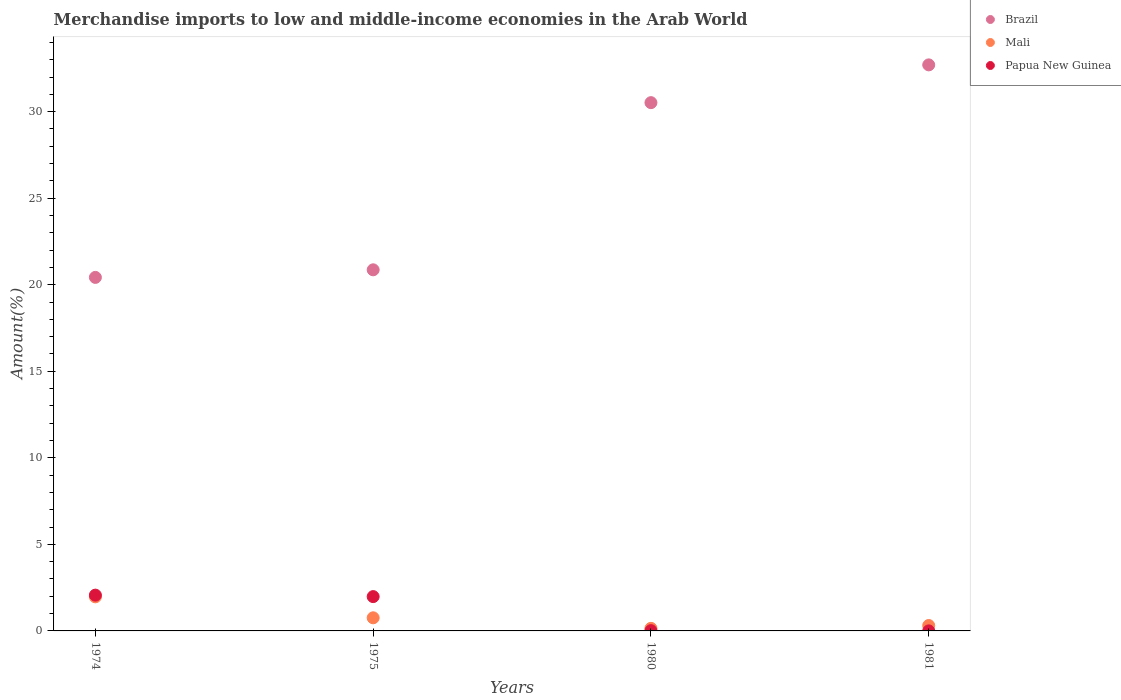Is the number of dotlines equal to the number of legend labels?
Offer a terse response. Yes. What is the percentage of amount earned from merchandise imports in Brazil in 1980?
Offer a very short reply. 30.52. Across all years, what is the maximum percentage of amount earned from merchandise imports in Papua New Guinea?
Your answer should be compact. 2.07. Across all years, what is the minimum percentage of amount earned from merchandise imports in Mali?
Keep it short and to the point. 0.15. In which year was the percentage of amount earned from merchandise imports in Papua New Guinea maximum?
Ensure brevity in your answer.  1974. In which year was the percentage of amount earned from merchandise imports in Brazil minimum?
Your answer should be compact. 1974. What is the total percentage of amount earned from merchandise imports in Brazil in the graph?
Ensure brevity in your answer.  104.51. What is the difference between the percentage of amount earned from merchandise imports in Brazil in 1974 and that in 1980?
Offer a very short reply. -10.1. What is the difference between the percentage of amount earned from merchandise imports in Papua New Guinea in 1981 and the percentage of amount earned from merchandise imports in Mali in 1974?
Provide a short and direct response. -1.97. What is the average percentage of amount earned from merchandise imports in Papua New Guinea per year?
Offer a terse response. 1.02. In the year 1980, what is the difference between the percentage of amount earned from merchandise imports in Mali and percentage of amount earned from merchandise imports in Papua New Guinea?
Keep it short and to the point. 0.13. What is the ratio of the percentage of amount earned from merchandise imports in Papua New Guinea in 1974 to that in 1981?
Provide a succinct answer. 876.47. Is the percentage of amount earned from merchandise imports in Brazil in 1980 less than that in 1981?
Ensure brevity in your answer.  Yes. Is the difference between the percentage of amount earned from merchandise imports in Mali in 1974 and 1981 greater than the difference between the percentage of amount earned from merchandise imports in Papua New Guinea in 1974 and 1981?
Provide a succinct answer. No. What is the difference between the highest and the second highest percentage of amount earned from merchandise imports in Mali?
Ensure brevity in your answer.  1.21. What is the difference between the highest and the lowest percentage of amount earned from merchandise imports in Mali?
Your response must be concise. 1.82. In how many years, is the percentage of amount earned from merchandise imports in Mali greater than the average percentage of amount earned from merchandise imports in Mali taken over all years?
Keep it short and to the point. 1. Does the percentage of amount earned from merchandise imports in Papua New Guinea monotonically increase over the years?
Give a very brief answer. No. Is the percentage of amount earned from merchandise imports in Papua New Guinea strictly less than the percentage of amount earned from merchandise imports in Mali over the years?
Offer a terse response. No. How many dotlines are there?
Ensure brevity in your answer.  3. What is the difference between two consecutive major ticks on the Y-axis?
Your answer should be compact. 5. Are the values on the major ticks of Y-axis written in scientific E-notation?
Your answer should be compact. No. What is the title of the graph?
Keep it short and to the point. Merchandise imports to low and middle-income economies in the Arab World. What is the label or title of the X-axis?
Keep it short and to the point. Years. What is the label or title of the Y-axis?
Keep it short and to the point. Amount(%). What is the Amount(%) in Brazil in 1974?
Make the answer very short. 20.42. What is the Amount(%) of Mali in 1974?
Your response must be concise. 1.97. What is the Amount(%) of Papua New Guinea in 1974?
Offer a terse response. 2.07. What is the Amount(%) in Brazil in 1975?
Ensure brevity in your answer.  20.86. What is the Amount(%) of Mali in 1975?
Ensure brevity in your answer.  0.76. What is the Amount(%) in Papua New Guinea in 1975?
Provide a short and direct response. 1.98. What is the Amount(%) of Brazil in 1980?
Offer a very short reply. 30.52. What is the Amount(%) in Mali in 1980?
Offer a very short reply. 0.15. What is the Amount(%) of Papua New Guinea in 1980?
Your answer should be compact. 0.02. What is the Amount(%) of Brazil in 1981?
Offer a very short reply. 32.7. What is the Amount(%) in Mali in 1981?
Make the answer very short. 0.31. What is the Amount(%) of Papua New Guinea in 1981?
Keep it short and to the point. 0. Across all years, what is the maximum Amount(%) of Brazil?
Your response must be concise. 32.7. Across all years, what is the maximum Amount(%) of Mali?
Offer a very short reply. 1.97. Across all years, what is the maximum Amount(%) in Papua New Guinea?
Ensure brevity in your answer.  2.07. Across all years, what is the minimum Amount(%) in Brazil?
Your answer should be compact. 20.42. Across all years, what is the minimum Amount(%) of Mali?
Your response must be concise. 0.15. Across all years, what is the minimum Amount(%) in Papua New Guinea?
Provide a succinct answer. 0. What is the total Amount(%) in Brazil in the graph?
Your response must be concise. 104.51. What is the total Amount(%) of Mali in the graph?
Your answer should be very brief. 3.19. What is the total Amount(%) in Papua New Guinea in the graph?
Your answer should be compact. 4.07. What is the difference between the Amount(%) in Brazil in 1974 and that in 1975?
Give a very brief answer. -0.44. What is the difference between the Amount(%) in Mali in 1974 and that in 1975?
Provide a succinct answer. 1.21. What is the difference between the Amount(%) in Papua New Guinea in 1974 and that in 1975?
Provide a short and direct response. 0.09. What is the difference between the Amount(%) of Brazil in 1974 and that in 1980?
Your answer should be very brief. -10.1. What is the difference between the Amount(%) in Mali in 1974 and that in 1980?
Make the answer very short. 1.82. What is the difference between the Amount(%) in Papua New Guinea in 1974 and that in 1980?
Offer a very short reply. 2.05. What is the difference between the Amount(%) of Brazil in 1974 and that in 1981?
Your response must be concise. -12.28. What is the difference between the Amount(%) in Mali in 1974 and that in 1981?
Provide a short and direct response. 1.66. What is the difference between the Amount(%) of Papua New Guinea in 1974 and that in 1981?
Your answer should be very brief. 2.07. What is the difference between the Amount(%) of Brazil in 1975 and that in 1980?
Give a very brief answer. -9.66. What is the difference between the Amount(%) of Mali in 1975 and that in 1980?
Offer a terse response. 0.61. What is the difference between the Amount(%) of Papua New Guinea in 1975 and that in 1980?
Make the answer very short. 1.97. What is the difference between the Amount(%) of Brazil in 1975 and that in 1981?
Provide a short and direct response. -11.84. What is the difference between the Amount(%) in Mali in 1975 and that in 1981?
Make the answer very short. 0.45. What is the difference between the Amount(%) in Papua New Guinea in 1975 and that in 1981?
Keep it short and to the point. 1.98. What is the difference between the Amount(%) of Brazil in 1980 and that in 1981?
Your answer should be compact. -2.18. What is the difference between the Amount(%) of Mali in 1980 and that in 1981?
Your response must be concise. -0.16. What is the difference between the Amount(%) in Papua New Guinea in 1980 and that in 1981?
Ensure brevity in your answer.  0.01. What is the difference between the Amount(%) of Brazil in 1974 and the Amount(%) of Mali in 1975?
Offer a terse response. 19.67. What is the difference between the Amount(%) of Brazil in 1974 and the Amount(%) of Papua New Guinea in 1975?
Ensure brevity in your answer.  18.44. What is the difference between the Amount(%) of Mali in 1974 and the Amount(%) of Papua New Guinea in 1975?
Ensure brevity in your answer.  -0.01. What is the difference between the Amount(%) in Brazil in 1974 and the Amount(%) in Mali in 1980?
Provide a short and direct response. 20.28. What is the difference between the Amount(%) in Brazil in 1974 and the Amount(%) in Papua New Guinea in 1980?
Provide a succinct answer. 20.41. What is the difference between the Amount(%) in Mali in 1974 and the Amount(%) in Papua New Guinea in 1980?
Keep it short and to the point. 1.95. What is the difference between the Amount(%) of Brazil in 1974 and the Amount(%) of Mali in 1981?
Your answer should be very brief. 20.11. What is the difference between the Amount(%) in Brazil in 1974 and the Amount(%) in Papua New Guinea in 1981?
Ensure brevity in your answer.  20.42. What is the difference between the Amount(%) of Mali in 1974 and the Amount(%) of Papua New Guinea in 1981?
Your response must be concise. 1.97. What is the difference between the Amount(%) in Brazil in 1975 and the Amount(%) in Mali in 1980?
Give a very brief answer. 20.71. What is the difference between the Amount(%) in Brazil in 1975 and the Amount(%) in Papua New Guinea in 1980?
Keep it short and to the point. 20.85. What is the difference between the Amount(%) of Mali in 1975 and the Amount(%) of Papua New Guinea in 1980?
Ensure brevity in your answer.  0.74. What is the difference between the Amount(%) of Brazil in 1975 and the Amount(%) of Mali in 1981?
Offer a terse response. 20.55. What is the difference between the Amount(%) in Brazil in 1975 and the Amount(%) in Papua New Guinea in 1981?
Your answer should be very brief. 20.86. What is the difference between the Amount(%) in Mali in 1975 and the Amount(%) in Papua New Guinea in 1981?
Your answer should be very brief. 0.76. What is the difference between the Amount(%) in Brazil in 1980 and the Amount(%) in Mali in 1981?
Your answer should be very brief. 30.21. What is the difference between the Amount(%) in Brazil in 1980 and the Amount(%) in Papua New Guinea in 1981?
Offer a very short reply. 30.52. What is the difference between the Amount(%) in Mali in 1980 and the Amount(%) in Papua New Guinea in 1981?
Offer a very short reply. 0.15. What is the average Amount(%) in Brazil per year?
Your answer should be compact. 26.13. What is the average Amount(%) of Mali per year?
Ensure brevity in your answer.  0.8. What is the average Amount(%) of Papua New Guinea per year?
Give a very brief answer. 1.02. In the year 1974, what is the difference between the Amount(%) of Brazil and Amount(%) of Mali?
Provide a short and direct response. 18.46. In the year 1974, what is the difference between the Amount(%) in Brazil and Amount(%) in Papua New Guinea?
Offer a very short reply. 18.36. In the year 1974, what is the difference between the Amount(%) in Mali and Amount(%) in Papua New Guinea?
Provide a short and direct response. -0.1. In the year 1975, what is the difference between the Amount(%) of Brazil and Amount(%) of Mali?
Ensure brevity in your answer.  20.1. In the year 1975, what is the difference between the Amount(%) of Brazil and Amount(%) of Papua New Guinea?
Give a very brief answer. 18.88. In the year 1975, what is the difference between the Amount(%) of Mali and Amount(%) of Papua New Guinea?
Ensure brevity in your answer.  -1.22. In the year 1980, what is the difference between the Amount(%) in Brazil and Amount(%) in Mali?
Offer a terse response. 30.37. In the year 1980, what is the difference between the Amount(%) of Brazil and Amount(%) of Papua New Guinea?
Keep it short and to the point. 30.51. In the year 1980, what is the difference between the Amount(%) in Mali and Amount(%) in Papua New Guinea?
Keep it short and to the point. 0.13. In the year 1981, what is the difference between the Amount(%) of Brazil and Amount(%) of Mali?
Your response must be concise. 32.39. In the year 1981, what is the difference between the Amount(%) in Brazil and Amount(%) in Papua New Guinea?
Provide a succinct answer. 32.7. In the year 1981, what is the difference between the Amount(%) in Mali and Amount(%) in Papua New Guinea?
Offer a very short reply. 0.31. What is the ratio of the Amount(%) in Brazil in 1974 to that in 1975?
Your response must be concise. 0.98. What is the ratio of the Amount(%) of Mali in 1974 to that in 1975?
Provide a succinct answer. 2.6. What is the ratio of the Amount(%) of Papua New Guinea in 1974 to that in 1975?
Provide a succinct answer. 1.04. What is the ratio of the Amount(%) of Brazil in 1974 to that in 1980?
Ensure brevity in your answer.  0.67. What is the ratio of the Amount(%) in Mali in 1974 to that in 1980?
Keep it short and to the point. 13.23. What is the ratio of the Amount(%) of Papua New Guinea in 1974 to that in 1980?
Give a very brief answer. 128.88. What is the ratio of the Amount(%) of Brazil in 1974 to that in 1981?
Ensure brevity in your answer.  0.62. What is the ratio of the Amount(%) in Mali in 1974 to that in 1981?
Ensure brevity in your answer.  6.32. What is the ratio of the Amount(%) in Papua New Guinea in 1974 to that in 1981?
Make the answer very short. 876.47. What is the ratio of the Amount(%) of Brazil in 1975 to that in 1980?
Your answer should be compact. 0.68. What is the ratio of the Amount(%) of Mali in 1975 to that in 1980?
Give a very brief answer. 5.1. What is the ratio of the Amount(%) of Papua New Guinea in 1975 to that in 1980?
Your answer should be compact. 123.56. What is the ratio of the Amount(%) of Brazil in 1975 to that in 1981?
Give a very brief answer. 0.64. What is the ratio of the Amount(%) in Mali in 1975 to that in 1981?
Make the answer very short. 2.43. What is the ratio of the Amount(%) of Papua New Guinea in 1975 to that in 1981?
Ensure brevity in your answer.  840.29. What is the ratio of the Amount(%) in Brazil in 1980 to that in 1981?
Keep it short and to the point. 0.93. What is the ratio of the Amount(%) of Mali in 1980 to that in 1981?
Offer a terse response. 0.48. What is the ratio of the Amount(%) of Papua New Guinea in 1980 to that in 1981?
Provide a short and direct response. 6.8. What is the difference between the highest and the second highest Amount(%) of Brazil?
Provide a succinct answer. 2.18. What is the difference between the highest and the second highest Amount(%) in Mali?
Provide a short and direct response. 1.21. What is the difference between the highest and the second highest Amount(%) of Papua New Guinea?
Provide a short and direct response. 0.09. What is the difference between the highest and the lowest Amount(%) of Brazil?
Make the answer very short. 12.28. What is the difference between the highest and the lowest Amount(%) of Mali?
Provide a succinct answer. 1.82. What is the difference between the highest and the lowest Amount(%) of Papua New Guinea?
Provide a short and direct response. 2.07. 